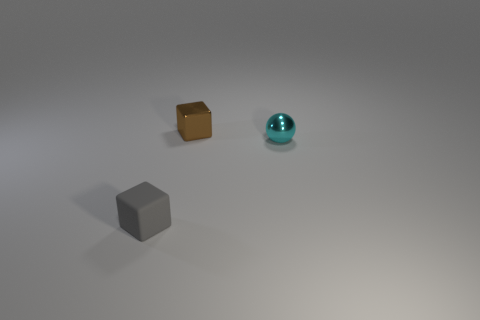What number of cyan objects are rubber objects or balls?
Keep it short and to the point. 1. What number of small cyan metal things are the same shape as the gray matte object?
Offer a very short reply. 0. What material is the small cyan thing?
Your response must be concise. Metal. Is the number of tiny brown objects that are left of the brown shiny block the same as the number of matte objects?
Offer a terse response. No. The cyan object that is the same size as the matte cube is what shape?
Provide a succinct answer. Sphere. There is a block that is right of the matte object; are there any tiny gray objects right of it?
Offer a very short reply. No. How many large objects are green rubber blocks or cyan metal things?
Provide a short and direct response. 0. Are there any balls of the same size as the gray object?
Give a very brief answer. Yes. How many rubber objects are gray objects or blue cubes?
Keep it short and to the point. 1. How many rubber things are there?
Offer a very short reply. 1. 